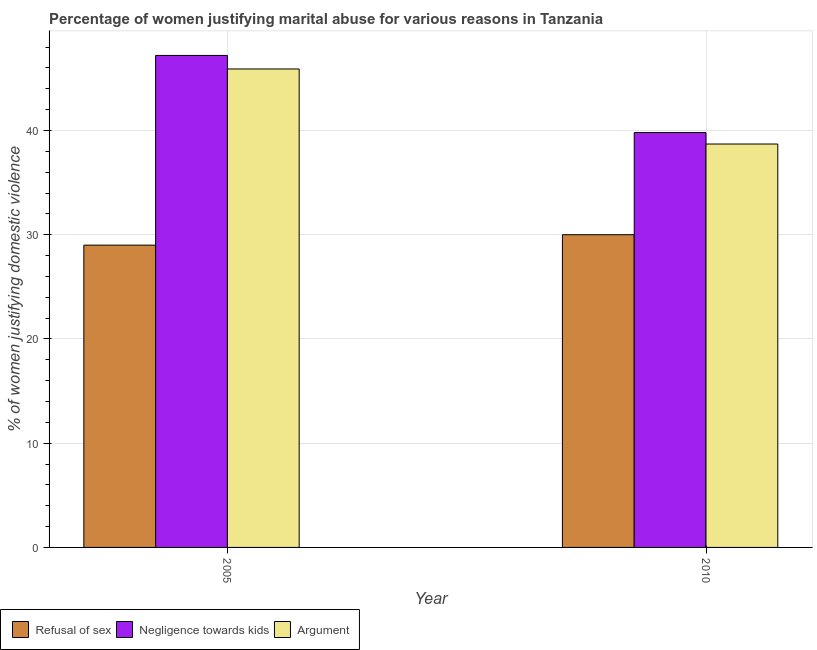Are the number of bars per tick equal to the number of legend labels?
Make the answer very short. Yes. How many bars are there on the 2nd tick from the left?
Offer a very short reply. 3. What is the label of the 1st group of bars from the left?
Your answer should be very brief. 2005. In how many cases, is the number of bars for a given year not equal to the number of legend labels?
Your response must be concise. 0. What is the percentage of women justifying domestic violence due to refusal of sex in 2005?
Offer a terse response. 29. Across all years, what is the maximum percentage of women justifying domestic violence due to refusal of sex?
Provide a short and direct response. 30. Across all years, what is the minimum percentage of women justifying domestic violence due to refusal of sex?
Provide a short and direct response. 29. In which year was the percentage of women justifying domestic violence due to arguments maximum?
Offer a very short reply. 2005. What is the total percentage of women justifying domestic violence due to refusal of sex in the graph?
Keep it short and to the point. 59. What is the difference between the percentage of women justifying domestic violence due to negligence towards kids in 2005 and that in 2010?
Offer a very short reply. 7.4. What is the difference between the percentage of women justifying domestic violence due to arguments in 2010 and the percentage of women justifying domestic violence due to negligence towards kids in 2005?
Your answer should be very brief. -7.2. What is the average percentage of women justifying domestic violence due to refusal of sex per year?
Keep it short and to the point. 29.5. In the year 2010, what is the difference between the percentage of women justifying domestic violence due to refusal of sex and percentage of women justifying domestic violence due to arguments?
Offer a terse response. 0. What is the ratio of the percentage of women justifying domestic violence due to refusal of sex in 2005 to that in 2010?
Offer a terse response. 0.97. Is the percentage of women justifying domestic violence due to negligence towards kids in 2005 less than that in 2010?
Keep it short and to the point. No. In how many years, is the percentage of women justifying domestic violence due to refusal of sex greater than the average percentage of women justifying domestic violence due to refusal of sex taken over all years?
Offer a terse response. 1. What does the 2nd bar from the left in 2010 represents?
Provide a succinct answer. Negligence towards kids. What does the 1st bar from the right in 2010 represents?
Keep it short and to the point. Argument. Is it the case that in every year, the sum of the percentage of women justifying domestic violence due to refusal of sex and percentage of women justifying domestic violence due to negligence towards kids is greater than the percentage of women justifying domestic violence due to arguments?
Provide a short and direct response. Yes. How many bars are there?
Offer a very short reply. 6. How many years are there in the graph?
Your answer should be very brief. 2. Are the values on the major ticks of Y-axis written in scientific E-notation?
Give a very brief answer. No. Does the graph contain grids?
Your answer should be compact. Yes. Where does the legend appear in the graph?
Offer a very short reply. Bottom left. How many legend labels are there?
Keep it short and to the point. 3. How are the legend labels stacked?
Offer a terse response. Horizontal. What is the title of the graph?
Your answer should be compact. Percentage of women justifying marital abuse for various reasons in Tanzania. What is the label or title of the Y-axis?
Make the answer very short. % of women justifying domestic violence. What is the % of women justifying domestic violence in Negligence towards kids in 2005?
Give a very brief answer. 47.2. What is the % of women justifying domestic violence of Argument in 2005?
Your answer should be compact. 45.9. What is the % of women justifying domestic violence of Refusal of sex in 2010?
Make the answer very short. 30. What is the % of women justifying domestic violence of Negligence towards kids in 2010?
Make the answer very short. 39.8. What is the % of women justifying domestic violence in Argument in 2010?
Your answer should be very brief. 38.7. Across all years, what is the maximum % of women justifying domestic violence in Refusal of sex?
Give a very brief answer. 30. Across all years, what is the maximum % of women justifying domestic violence of Negligence towards kids?
Make the answer very short. 47.2. Across all years, what is the maximum % of women justifying domestic violence of Argument?
Your answer should be very brief. 45.9. Across all years, what is the minimum % of women justifying domestic violence in Negligence towards kids?
Ensure brevity in your answer.  39.8. Across all years, what is the minimum % of women justifying domestic violence in Argument?
Provide a succinct answer. 38.7. What is the total % of women justifying domestic violence of Refusal of sex in the graph?
Offer a terse response. 59. What is the total % of women justifying domestic violence of Negligence towards kids in the graph?
Ensure brevity in your answer.  87. What is the total % of women justifying domestic violence in Argument in the graph?
Your answer should be compact. 84.6. What is the difference between the % of women justifying domestic violence in Argument in 2005 and that in 2010?
Offer a very short reply. 7.2. What is the difference between the % of women justifying domestic violence of Refusal of sex in 2005 and the % of women justifying domestic violence of Argument in 2010?
Your answer should be very brief. -9.7. What is the average % of women justifying domestic violence of Refusal of sex per year?
Offer a terse response. 29.5. What is the average % of women justifying domestic violence of Negligence towards kids per year?
Ensure brevity in your answer.  43.5. What is the average % of women justifying domestic violence in Argument per year?
Provide a short and direct response. 42.3. In the year 2005, what is the difference between the % of women justifying domestic violence of Refusal of sex and % of women justifying domestic violence of Negligence towards kids?
Your answer should be compact. -18.2. In the year 2005, what is the difference between the % of women justifying domestic violence in Refusal of sex and % of women justifying domestic violence in Argument?
Ensure brevity in your answer.  -16.9. In the year 2005, what is the difference between the % of women justifying domestic violence of Negligence towards kids and % of women justifying domestic violence of Argument?
Your response must be concise. 1.3. In the year 2010, what is the difference between the % of women justifying domestic violence in Refusal of sex and % of women justifying domestic violence in Negligence towards kids?
Offer a very short reply. -9.8. In the year 2010, what is the difference between the % of women justifying domestic violence in Refusal of sex and % of women justifying domestic violence in Argument?
Provide a succinct answer. -8.7. What is the ratio of the % of women justifying domestic violence of Refusal of sex in 2005 to that in 2010?
Keep it short and to the point. 0.97. What is the ratio of the % of women justifying domestic violence of Negligence towards kids in 2005 to that in 2010?
Provide a succinct answer. 1.19. What is the ratio of the % of women justifying domestic violence in Argument in 2005 to that in 2010?
Offer a terse response. 1.19. What is the difference between the highest and the lowest % of women justifying domestic violence of Refusal of sex?
Your answer should be very brief. 1. 